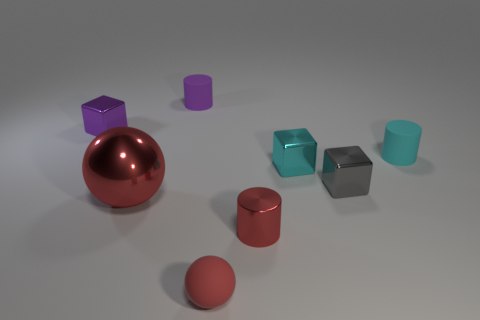What shape is the purple thing that is made of the same material as the gray thing?
Ensure brevity in your answer.  Cube. How many other objects are there of the same color as the big object?
Provide a succinct answer. 2. Are there more small gray objects right of the metallic sphere than red cylinders that are to the left of the shiny cylinder?
Provide a succinct answer. Yes. What size is the purple block that is the same material as the cyan block?
Offer a very short reply. Small. What number of small purple blocks are on the left side of the tiny ball?
Make the answer very short. 1. There is a cylinder in front of the cyan metallic cube in front of the tiny purple cylinder on the left side of the red rubber thing; what is its color?
Keep it short and to the point. Red. There is a tiny block that is to the left of the tiny red shiny cylinder; is it the same color as the matte cylinder on the left side of the red rubber ball?
Make the answer very short. Yes. There is a red object that is left of the tiny purple object on the right side of the large sphere; what shape is it?
Give a very brief answer. Sphere. Is there a red ball that has the same size as the red shiny cylinder?
Your response must be concise. Yes. What number of cyan metallic objects are the same shape as the purple rubber object?
Your answer should be compact. 0. 